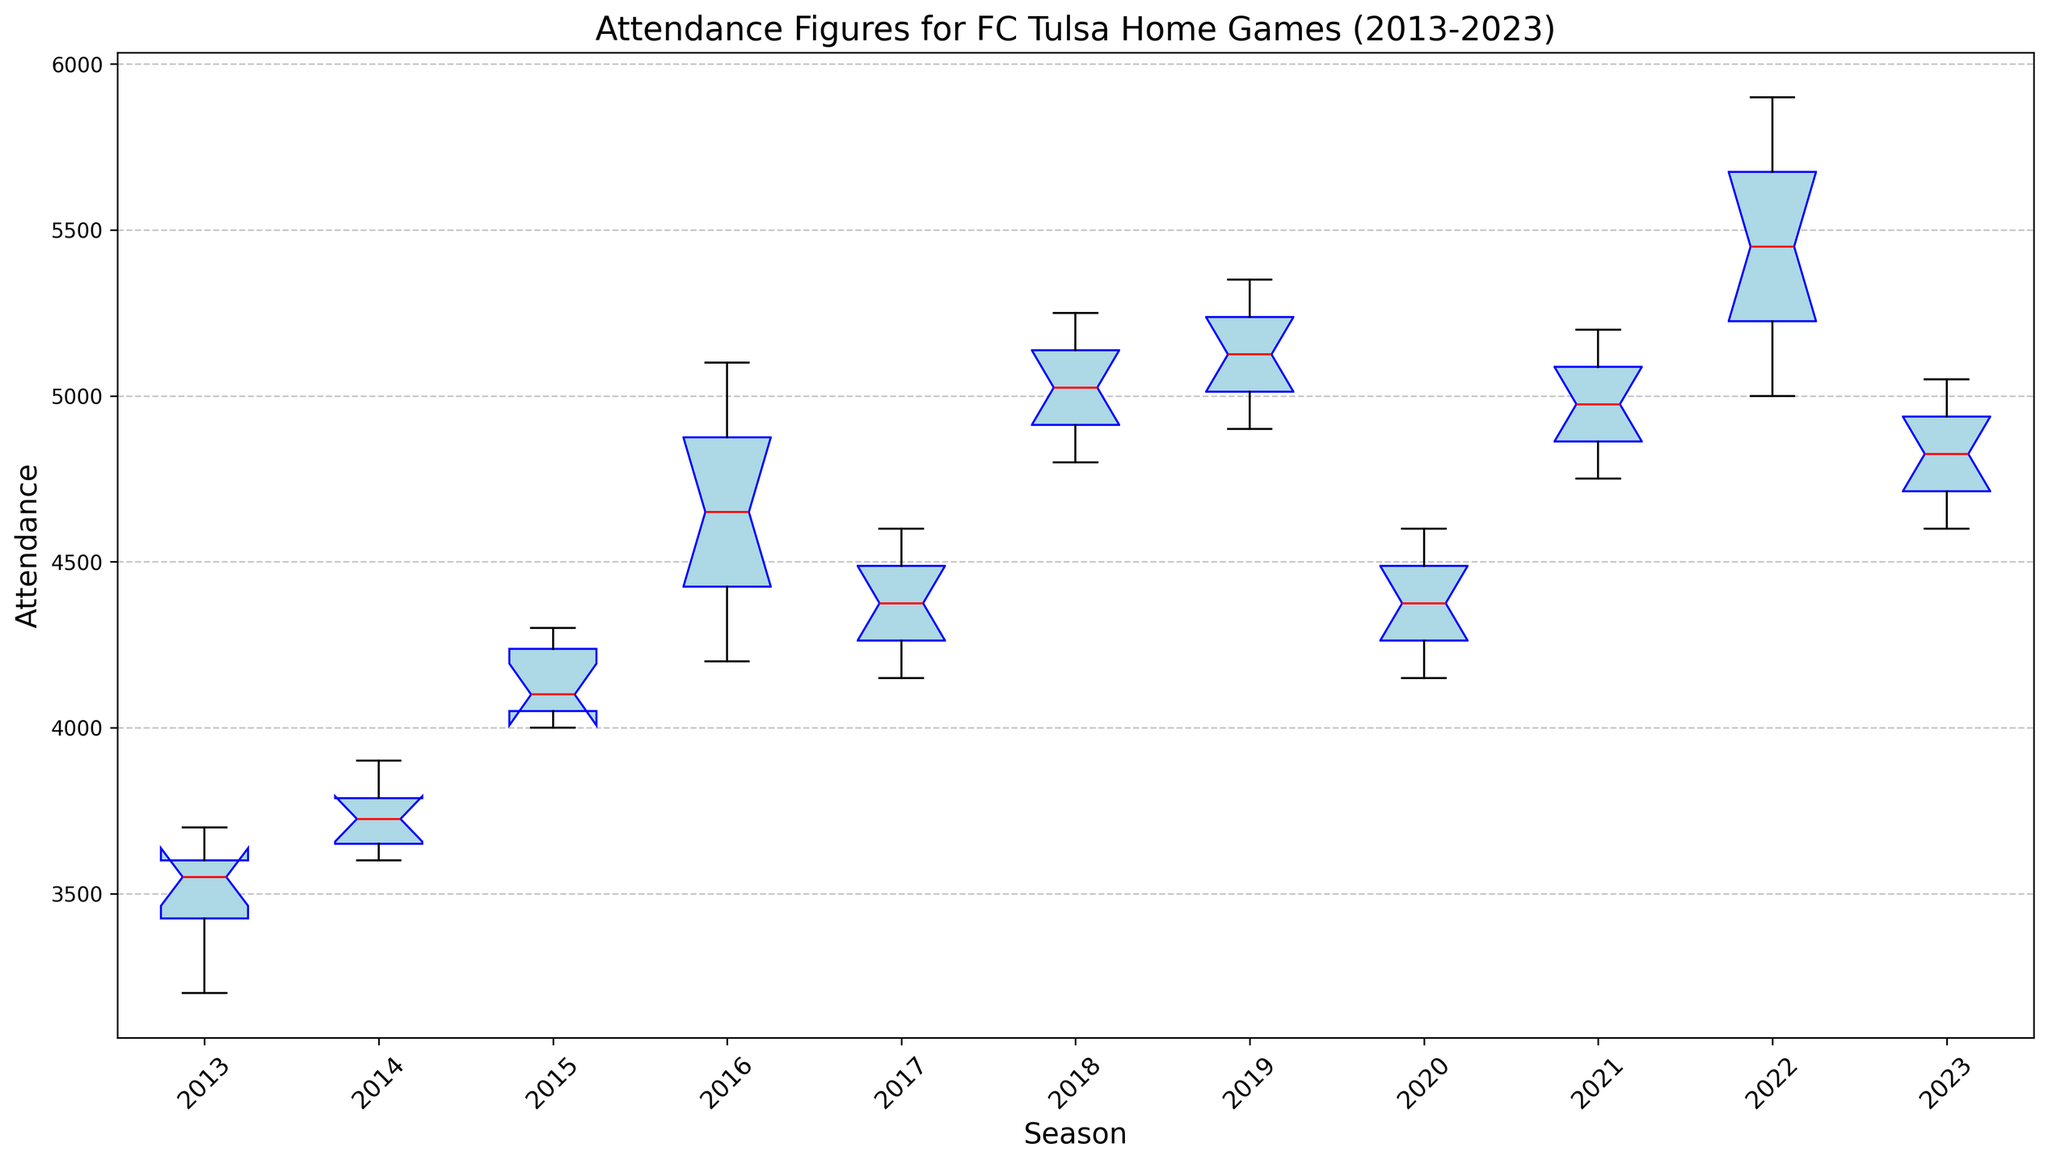How does the median attendance in 2013 compare to the median attendance in 2022? Look at the red lines in the boxes for 2013 and 2022. Compare their positions. In this case, the median attendance in 2022 is higher than in 2013.
Answer: 2022's median is higher Which season has the highest median attendance? Look for the season with the highest red median line across all the boxes. In this case, it is 2022.
Answer: 2022 Considering the interquartile range (IQR), which season appears to have the highest variability in attendance? The IQR is the length of the box representing the middle 50% of the data. Look for the longest box. In this case, it is 2016.
Answer: 2016 What is the range of attendances for the 2015 season? Identify the whiskers for 2015, which extend from the minimum to the maximum value. The range is the difference between these two. Maximum (4300) - Minimum (4000) = 300.
Answer: 300 Are there any outliers in attendance data for the 2023 season? Outliers are typically represented as individual points outside the whiskers. For 2023, there are no such points visible.
Answer: No How do the median attendances of 2020 and 2019 compare? Compare the positions of the red median lines for both 2020 and 2019. The median attendance for 2020 is lower than 2019.
Answer: 2020's median is lower In which season did the attendance first reach or exceed 5000? Look for the first season box where the upper whisker extends to or beyond 5000. In this case, it is 2016.
Answer: 2016 What is the median attendance for the 2018 season? Identify the red line in the 2018 box plot, which represents the median. For 2018, it is around 5050.
Answer: 5050 How does the overall trend of attendance from 2013 to 2023 appear? Visually assess the median lines across the seasons from left to right. There is a general increasing trend from 2013 to 2022, with a slight drop-off in 2023.
Answer: Increasing with a drop What is the difference between the medians of the highest and lowest median attendance seasons? Identify the highest and lowest median lines (2022 and 2013 respectively) and calculate the difference. For 2022, the median is around 5500; for 2013, it is approximately 3550. Difference = 5500 - 3550 = 1950.
Answer: 1950 